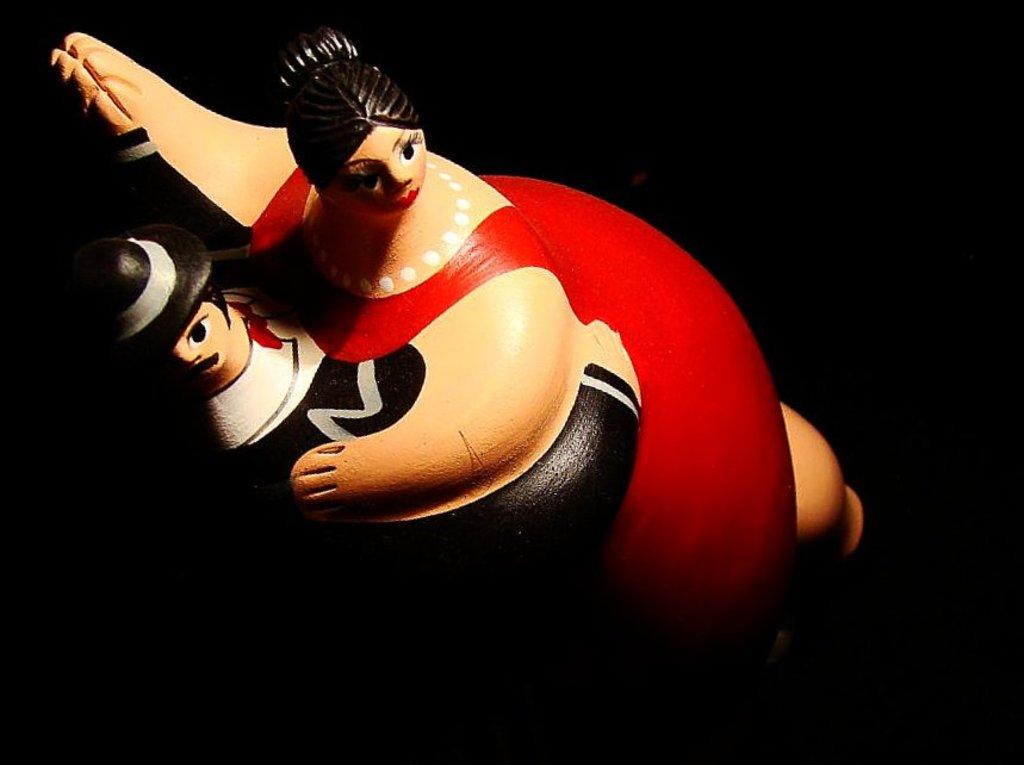What is the main subject in the middle of the image? There is a toy in the middle of the image. What can be observed about the background of the image? The background of the image is dark. How many ants can be seen crawling on the toy in the image? There are no ants present in the image; it only features a toy in the middle of the image with a dark background. 